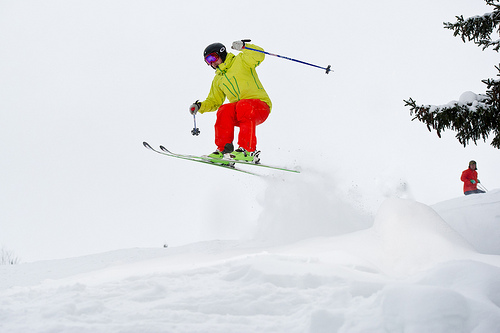Detail the equipment the skier is using. The skier is equipped with a set of carving skis, poles with ergonomic grips, and a protective helmet. Their goggles and bright ski attire are designed for visibility and safety. How essential is the gear they're using for this type of activity? The gear is crucial not only for performance, allowing for precise control and maneuverability, but also for safety, protecting against impacts and harsh weather conditions. 